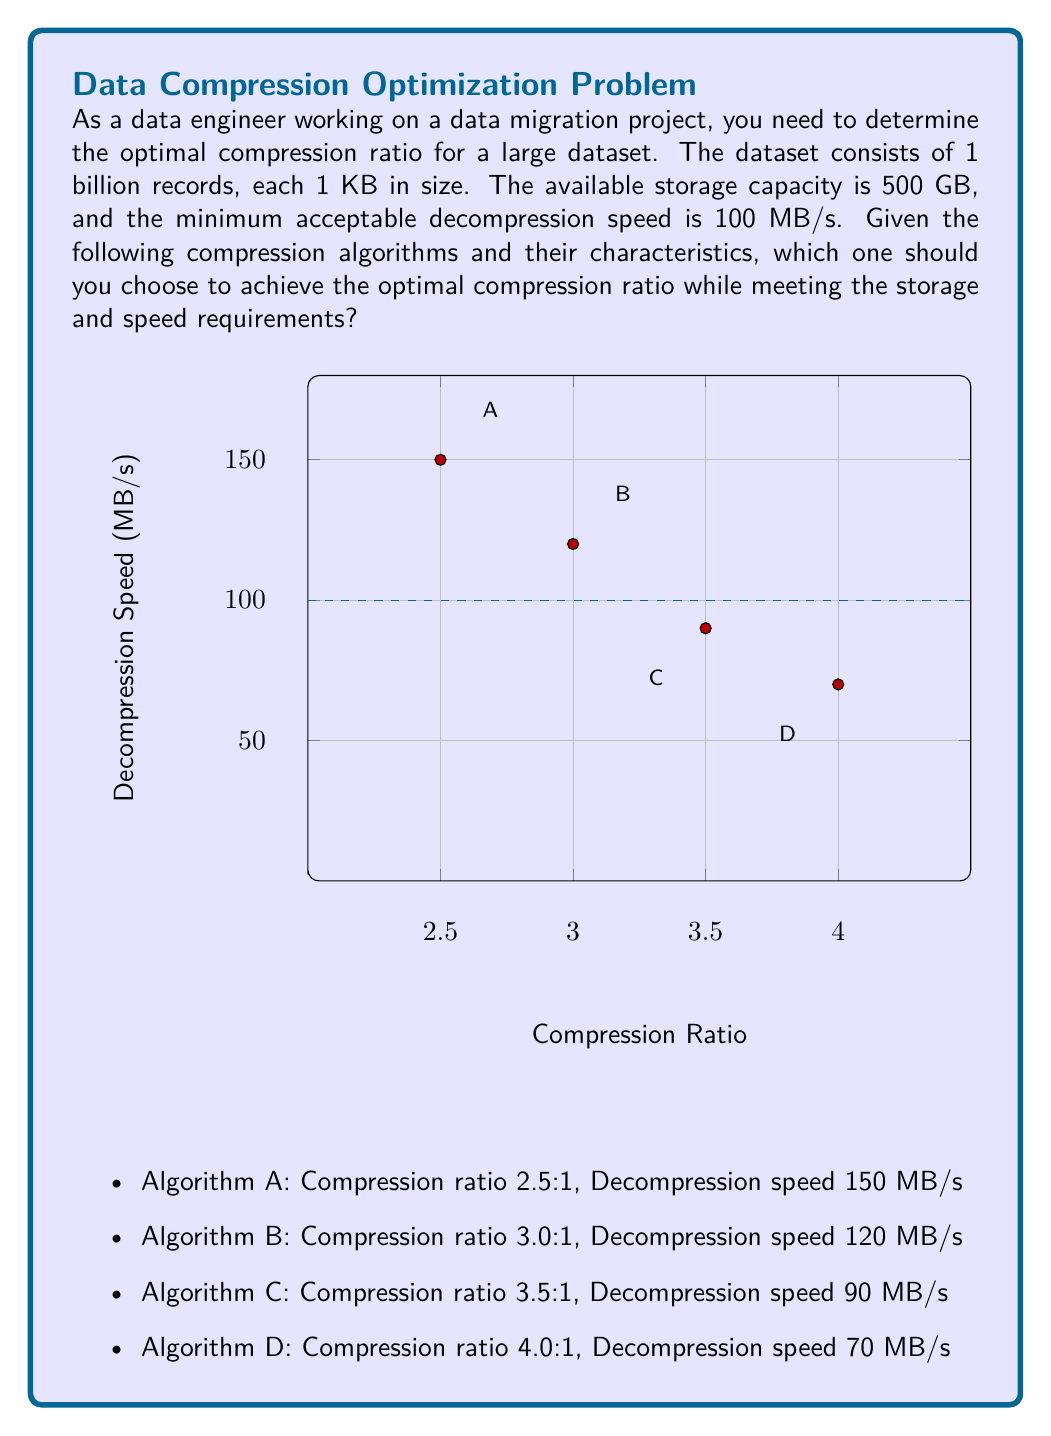Give your solution to this math problem. Let's approach this problem step-by-step:

1. Calculate the original dataset size:
   $$ \text{Original size} = 1 \text{ billion} \times 1 \text{ KB} = 10^9 \text{ KB} = 1000 \text{ GB} $$

2. Calculate the required compression ratio to fit the data in 500 GB:
   $$ \text{Required ratio} = \frac{\text{Original size}}{\text{Available storage}} = \frac{1000 \text{ GB}}{500 \text{ GB}} = 2:1 $$

3. Evaluate each algorithm:
   A. Ratio 2.5:1 > 2:1, Speed 150 MB/s > 100 MB/s (Meets both requirements)
   B. Ratio 3.0:1 > 2:1, Speed 120 MB/s > 100 MB/s (Meets both requirements)
   C. Ratio 3.5:1 > 2:1, Speed 90 MB/s < 100 MB/s (Fails speed requirement)
   D. Ratio 4.0:1 > 2:1, Speed 70 MB/s < 100 MB/s (Fails speed requirement)

4. Among the algorithms that meet both requirements (A and B), choose the one with the higher compression ratio to optimize storage efficiency.

Therefore, Algorithm B provides the optimal compression ratio (3.0:1) while meeting both the storage and speed requirements.
Answer: Algorithm B (3.0:1 ratio, 120 MB/s) 